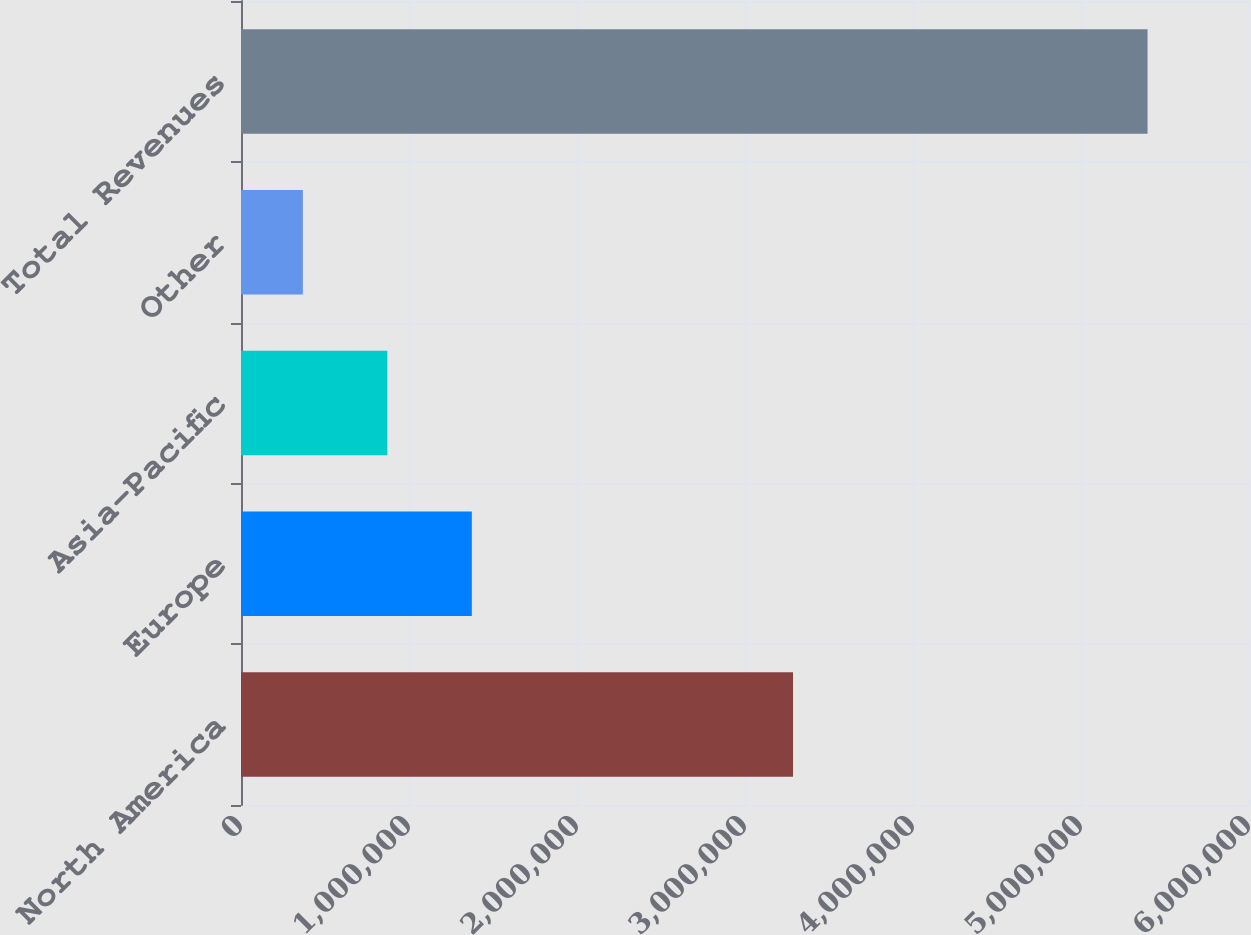Convert chart. <chart><loc_0><loc_0><loc_500><loc_500><bar_chart><fcel>North America<fcel>Europe<fcel>Asia-Pacific<fcel>Other<fcel>Total Revenues<nl><fcel>3.2859e+06<fcel>1.37384e+06<fcel>871052<fcel>368260<fcel>5.39618e+06<nl></chart> 